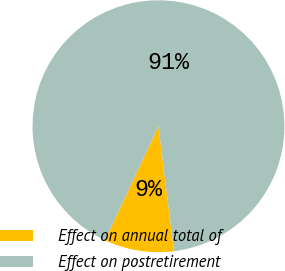<chart> <loc_0><loc_0><loc_500><loc_500><pie_chart><fcel>Effect on annual total of<fcel>Effect on postretirement<nl><fcel>8.95%<fcel>91.05%<nl></chart> 